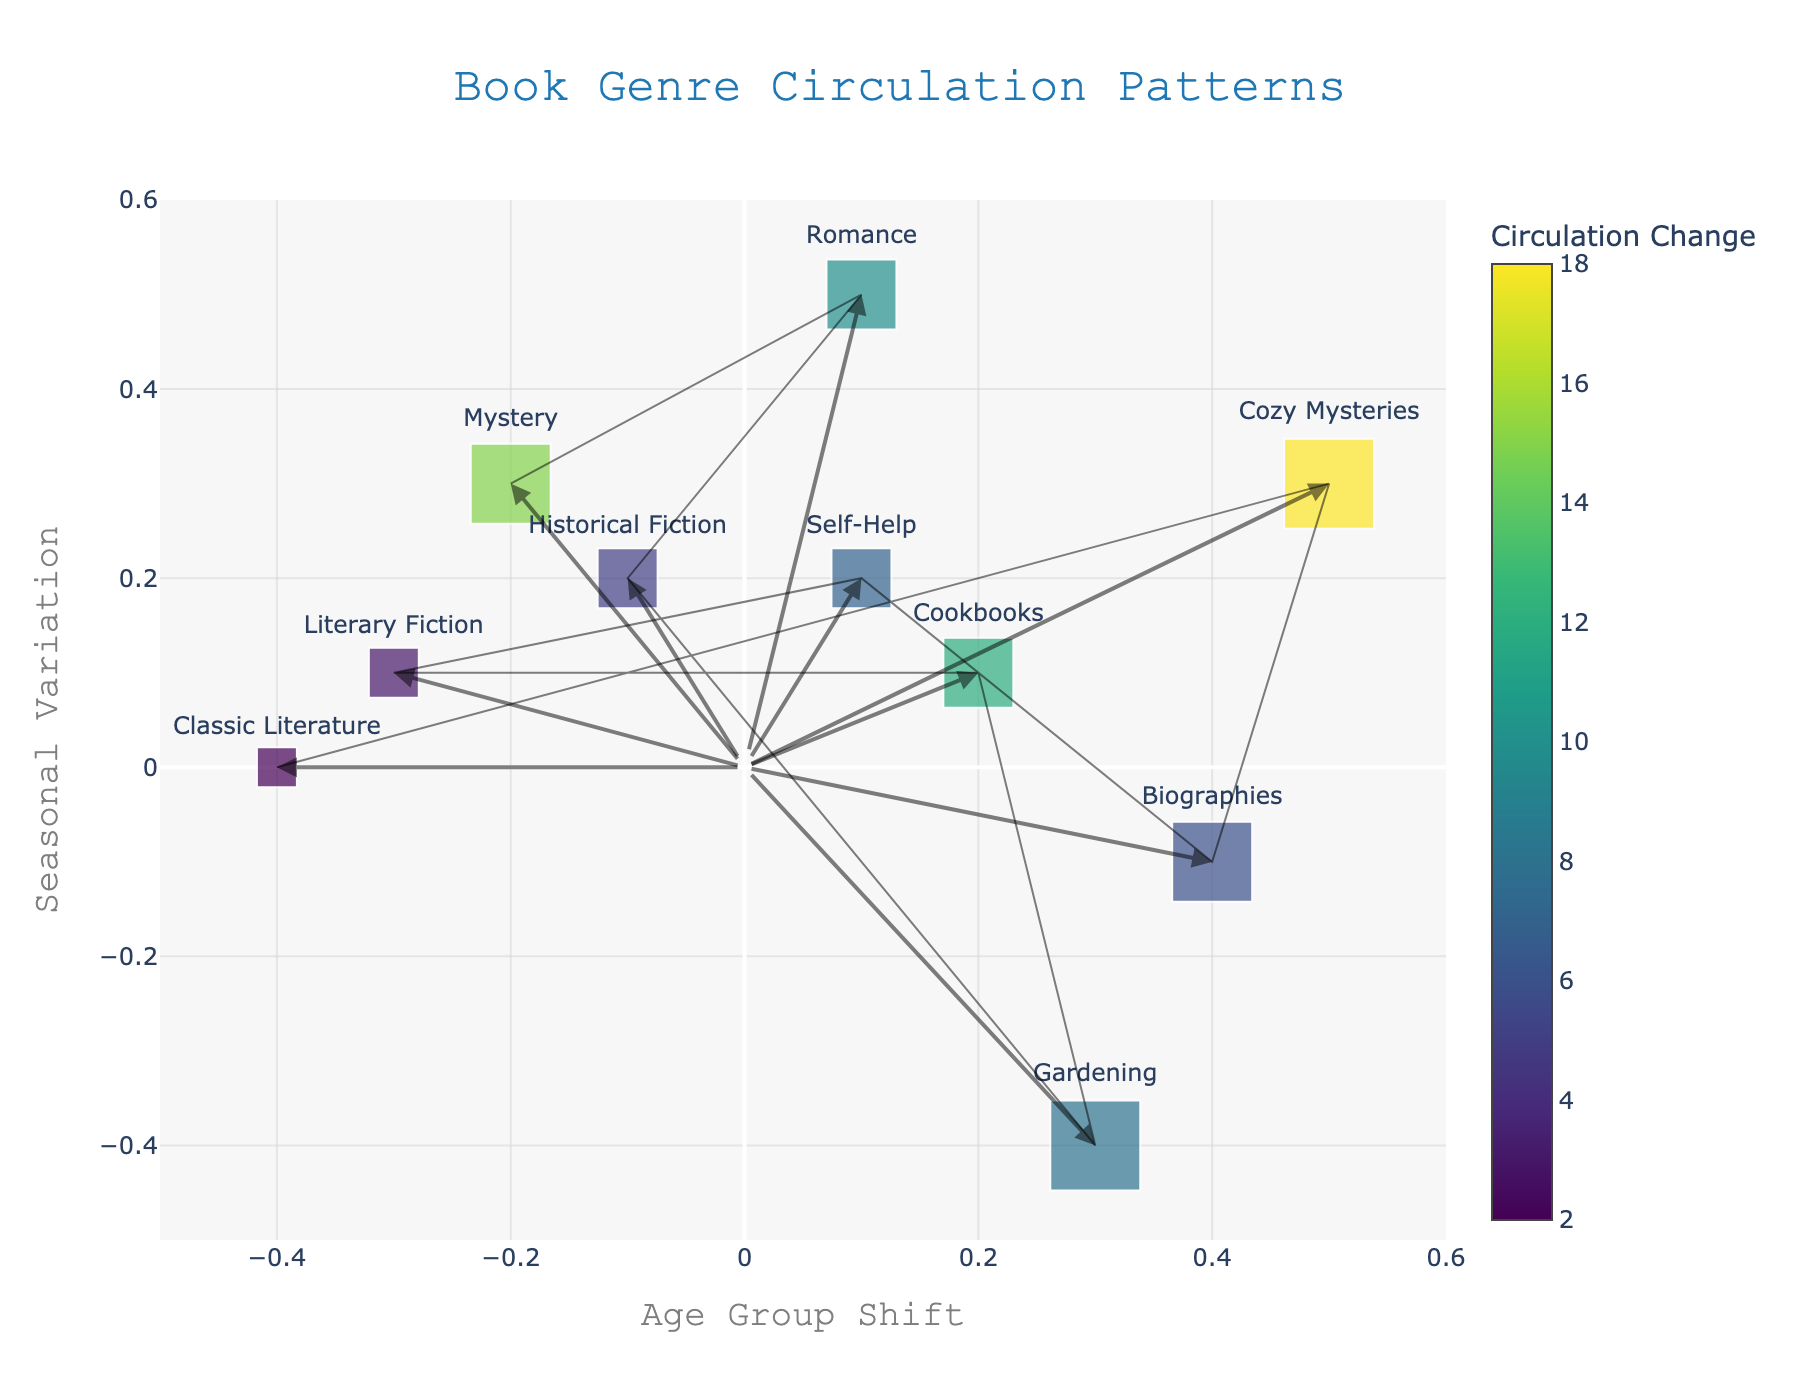How many genres are represented in the plot? There are ten genres listed in the data provided. Each genre is plotted as a point on the quiver plot, labeled with names like "Mystery," "Romance," etc.
Answer: 10 Which genre has the highest Popularity Score? The Popularity Score is represented by the size of the marker. The largest marker corresponds to the genre "Cozy Mysteries" with a Popularity Score of 9.
Answer: Cozy Mysteries What is the title of the plot? The title is found at the top of the plot. It reads "Book Genre Circulation Patterns."
Answer: Book Genre Circulation Patterns Which genre has the largest Circulation Change and what is its value? By referring to the color bar and corresponding colors of the markers, "Cozy Mysteries" has the largest Circulation Change with a value of 18.
Answer: Cozy Mysteries, 18 Compare the Age Group Shift for "Gardening" and "Biographies." Which one has a higher value? The "Age Group Shift" axis shows the values for each genre. "Biographies" has a shift of 0.4, while "Gardening" has a shift of 0.3. Thus, "Biographies" has a higher value.
Answer: Biographies Which genre has the least Seasonal Variation? By examining the values on the "Seasonal Variation" axis, "Gardening" has the lowest value at -0.4.
Answer: Gardening What is the Seasonal Variation of the "Classic Literature" genre and how does it compare to "Literary Fiction"? "Classic Literature" has a Seasonal Variation of 0, as indicated by its position on the y-axis. "Literary Fiction" has a value of 0.1. Therefore, "Literary Fiction" has a slightly higher Seasonal Variation.
Answer: Classic Literature: 0, Literary Fiction: 0.1 Which genre’s Age Group Shift shows the smallest increase, and what is its value? "Classic Literature" has the smallest increase in Age Group Shift with a value of -0.4. This can be seen by identifying the leftmost point on the x-axis.
Answer: Classic Literature, -0.4 Identify the genre with both high Circulation Change and high Seasonal Variation. Searching for high values in both Circulation Change (color) and Seasonal Variation (y-axis), "Cozy Mysteries" appears prominent with high values in both categories.
Answer: Cozy Mysteries How does the Popularity Score of "Mystery" compare to that of "Historical Fiction"? "Mystery" has a Popularity Score of 8, while "Historical Fiction" has a score of 6. Therefore, "Mystery" is more popular than "Historical Fiction."
Answer: Mystery > Historical Fiction 